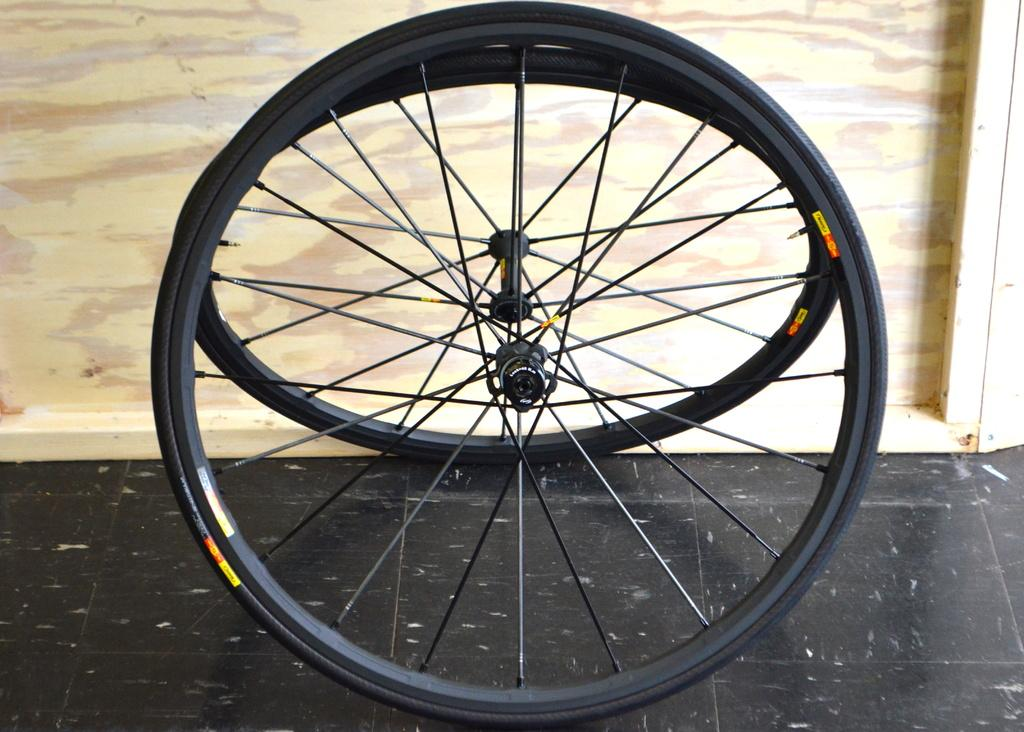What is the main object in the foreground of the image? There is a bicycle wheel in the foreground of the image. What can be seen at the bottom of the image? The floor is visible at the bottom of the image. What is located in the background of the image? There appears to be a mirror and a wooden object in the background of the image. How many fingers can be seen holding the camera in the image? There is no camera or fingers present in the image. What type of thread is being used to sew the wooden object in the image? There is no thread or sewing activity present in the image. 